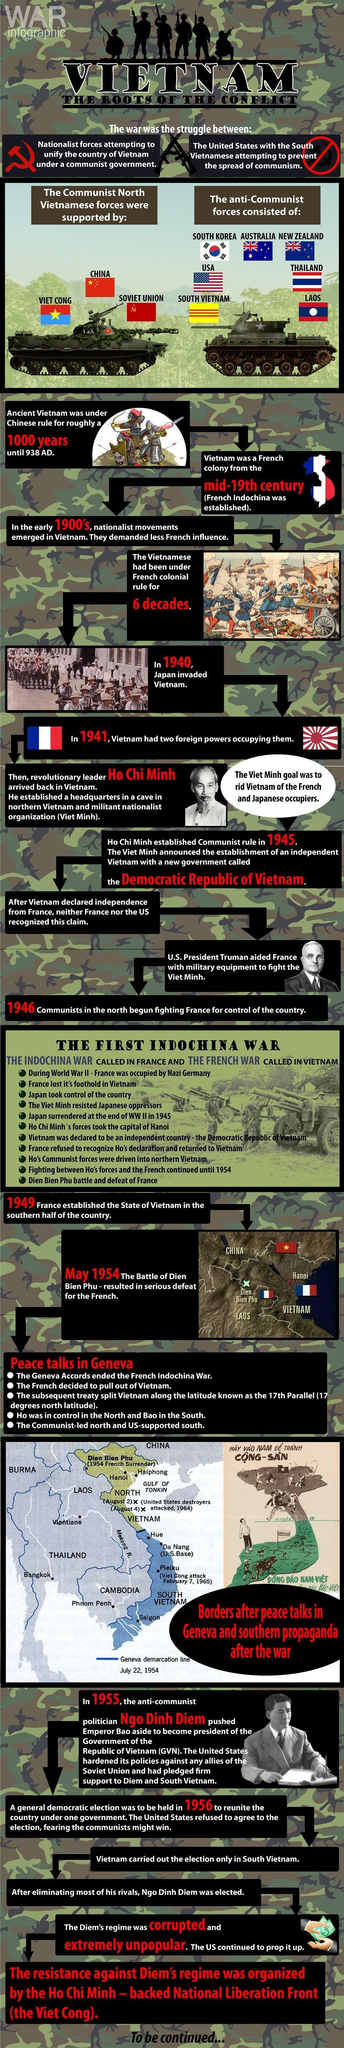Who occupied Vietnam first, French or Japan?
Answer the question with a short phrase. French For how many "years" was Vietnam under the French colonial rule? 60 Who established the "French Indochina"  - France, India or China? France Who established Viet Minh? Ho Chi Minh Who disagreed with the general democratic election in 1956? The United States Who were the two foreign powers occupying Vietnam in 1941? French, Japanese How many countries supported the anti communist forces? 7 Which two countries did not accept Vietnam's declaration of independence in1945? France, US Whom did United States support, North Vietnam or South Vietnam? South Vietnam Who ruled Vietnam in the mid 19th century- Chinese, French or Japanese? French After the IndoChina war, who was the leader of North Vietnam? Ho Chi Minh For how many "centuries"  was Vietnam under the Chinese rule? 10 Who supported the communist North Vietnamese forces? China, Soviet union, Viet cong What was the government formed by Ho Chi Minh in 1945? Democratic republic of Vietnam Who occupied Vietnam first, France or China? China After the IndoChina war, under whose leadership was South Vietnam? Bao Who ruled Vietnam before 938 AD - Chinese, French or Japanese? Chinese In which battle were the French finally defeated and when? The Battle of Dien Bien Phu, May 1954 When did the first Indochina war begin? 1946 Who overthrew emperor Bao and when? Ngo Dinh Diem, 1955 Who was defeated in the first Indochina war? France 